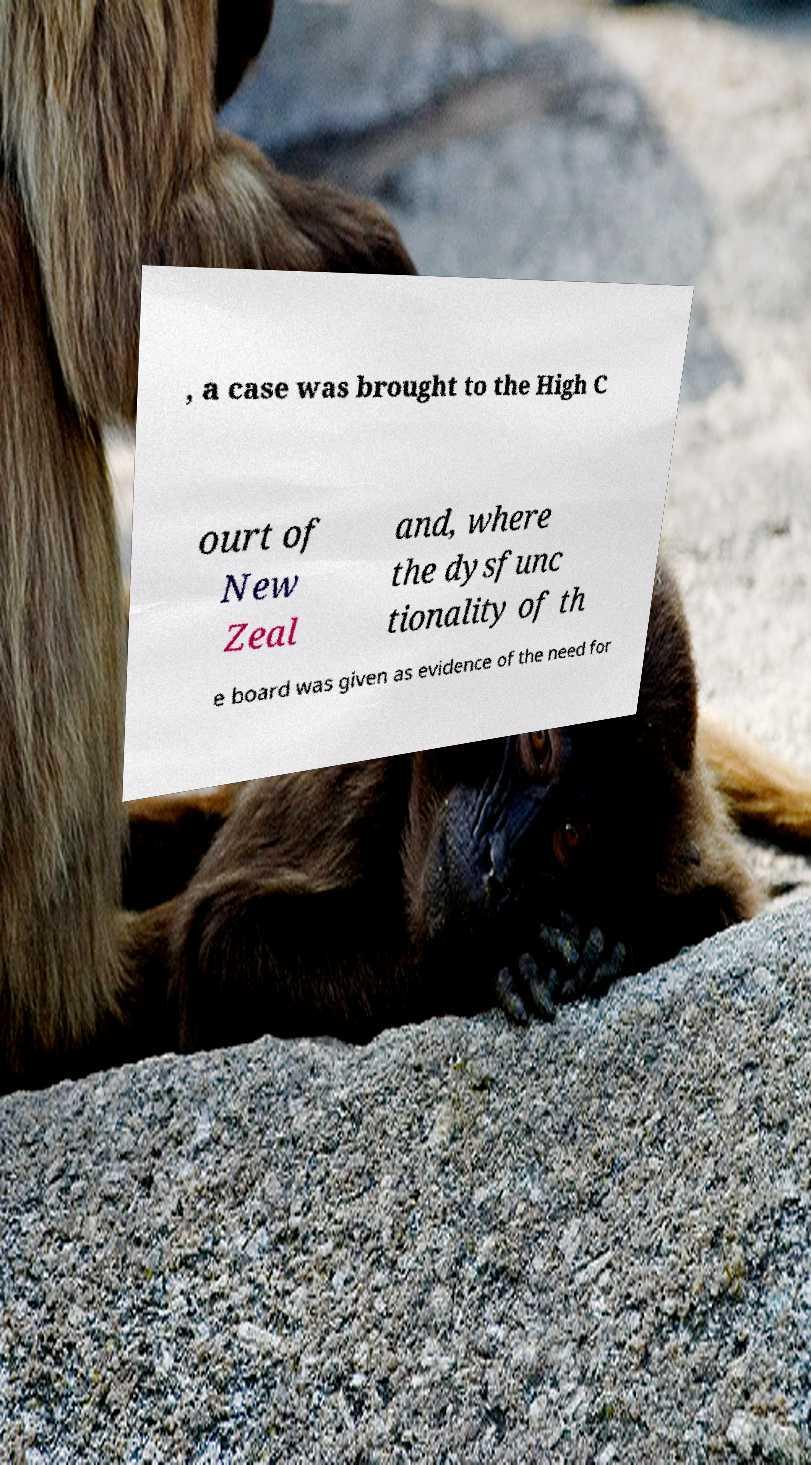There's text embedded in this image that I need extracted. Can you transcribe it verbatim? , a case was brought to the High C ourt of New Zeal and, where the dysfunc tionality of th e board was given as evidence of the need for 